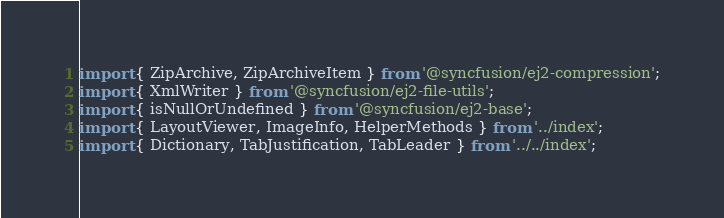<code> <loc_0><loc_0><loc_500><loc_500><_TypeScript_>
import { ZipArchive, ZipArchiveItem } from '@syncfusion/ej2-compression';
import { XmlWriter } from '@syncfusion/ej2-file-utils';
import { isNullOrUndefined } from '@syncfusion/ej2-base';
import { LayoutViewer, ImageInfo, HelperMethods } from '../index';
import { Dictionary, TabJustification, TabLeader } from '../../index';</code> 